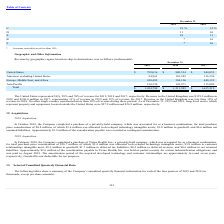According to Fitbit's financial document, What is the amount of revenue in the United Kingdom in 2019? According to the financial document, $159.9 million. The relevant text states: "7, respectively. Revenue in the United Kingdom was $159.9 million in..." Also, What is the value of long-lived assets located outside the United States as of December 31, 2018? According to the financial document, $36.9 million. The relevant text states: "d outside the United States were $27.9 million and $36.9 million, respectively...." Also, What is the percentage constitution of revenue from the United States for 2019? According to the financial document, 56%. The relevant text states: "The United States represented 56%, 58% and 58% of revenue for 2019, 2018 and 2017, respectively. Revenue in the United Kingdom was $1..." Also, can you calculate: What is the average revenue from the United States from 2017 to 2019? To answer this question, I need to perform calculations using the financial data. The calculation is: (799,016+880,534+944,052)/3, which equals 874534 (in thousands). This is based on the information: "United States $ 799,016 $ 880,534 $ 944,052 United States $ 799,016 $ 880,534 $ 944,052 United States $ 799,016 $ 880,534 $ 944,052..." The key data points involved are: 799,016, 880,534, 944,052. Also, can you calculate: What is the percentage constitution of revenue from Asia Pacific among the total revenue in 2019? Based on the calculation: 130,326/1,434,788, the result is 9.08 (percentage). This is based on the information: "Asia Pacific 130,326 145,971 115,002 Total $ 1,434,788 $ 1,511,983 $ 1,615,519..." The key data points involved are: 1,434,788, 130,326. Also, can you calculate: What is the difference in total revenue between 2017 and 2018? Based on the calculation: 1,615,519-1,511,983, the result is 103536 (in thousands). This is based on the information: "Total $ 1,434,788 $ 1,511,983 $ 1,615,519 Total $ 1,434,788 $ 1,511,983 $ 1,615,519..." The key data points involved are: 1,511,983, 1,615,519. 